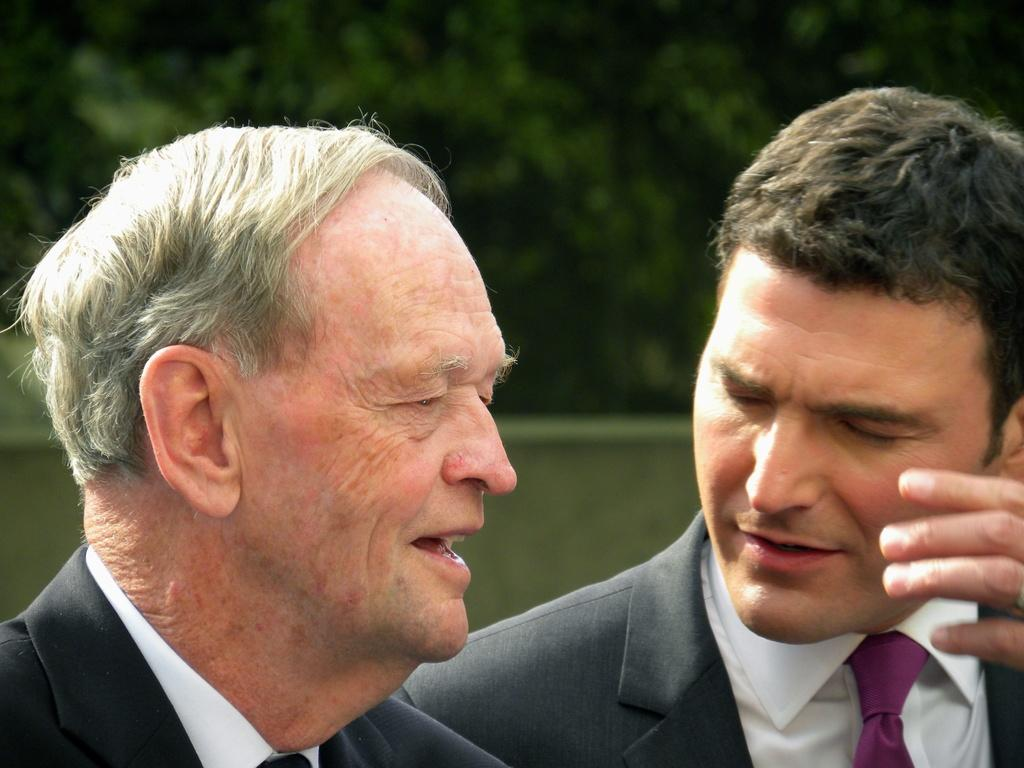How many people are in the image? There are two men in the image. What are the men wearing? The men are wearing formal dress. Can you describe the background of the image? The background of the image is blurred. Is there a woman wearing a jewel in the image? There is no woman or jewel present in the image; it features two men wearing formal dress. Can you see a slope in the background of the image? The background of the image is blurred, and there is no indication of a slope. 